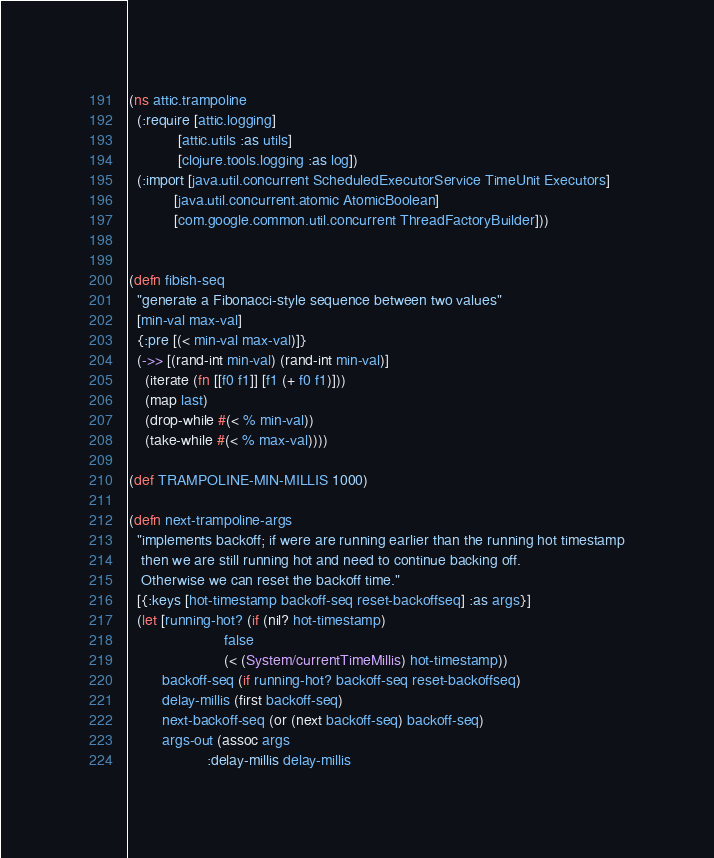Convert code to text. <code><loc_0><loc_0><loc_500><loc_500><_Clojure_>(ns attic.trampoline
  (:require [attic.logging]
            [attic.utils :as utils]
            [clojure.tools.logging :as log])
  (:import [java.util.concurrent ScheduledExecutorService TimeUnit Executors]
           [java.util.concurrent.atomic AtomicBoolean]
           [com.google.common.util.concurrent ThreadFactoryBuilder]))


(defn fibish-seq
  "generate a Fibonacci-style sequence between two values"
  [min-val max-val]
  {:pre [(< min-val max-val)]}
  (->> [(rand-int min-val) (rand-int min-val)]
    (iterate (fn [[f0 f1]] [f1 (+ f0 f1)]))
    (map last)
    (drop-while #(< % min-val))
    (take-while #(< % max-val))))

(def TRAMPOLINE-MIN-MILLIS 1000)

(defn next-trampoline-args
  "implements backoff; if were are running earlier than the running hot timestamp
   then we are still running hot and need to continue backing off.
   Otherwise we can reset the backoff time."
  [{:keys [hot-timestamp backoff-seq reset-backoffseq] :as args}]
  (let [running-hot? (if (nil? hot-timestamp)
                       false
                       (< (System/currentTimeMillis) hot-timestamp))
        backoff-seq (if running-hot? backoff-seq reset-backoffseq)
        delay-millis (first backoff-seq)
        next-backoff-seq (or (next backoff-seq) backoff-seq)
        args-out (assoc args
                   :delay-millis delay-millis</code> 